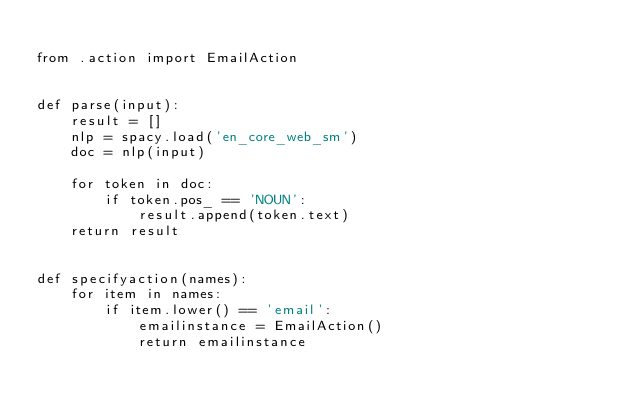<code> <loc_0><loc_0><loc_500><loc_500><_Python_>
from .action import EmailAction


def parse(input):
    result = []
    nlp = spacy.load('en_core_web_sm')
    doc = nlp(input)

    for token in doc:
        if token.pos_ == 'NOUN':
            result.append(token.text)
    return result


def specifyaction(names):
    for item in names:
        if item.lower() == 'email':
            emailinstance = EmailAction()
            return emailinstance

</code> 